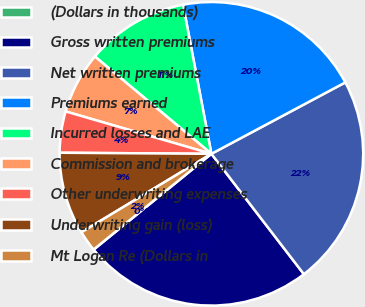Convert chart to OTSL. <chart><loc_0><loc_0><loc_500><loc_500><pie_chart><fcel>(Dollars in thousands)<fcel>Gross written premiums<fcel>Net written premiums<fcel>Premiums earned<fcel>Incurred losses and LAE<fcel>Commission and brokerage<fcel>Other underwriting expenses<fcel>Underwriting gain (loss)<fcel>Mt Logan Re (Dollars in<nl><fcel>0.02%<fcel>24.55%<fcel>22.37%<fcel>20.19%<fcel>10.94%<fcel>6.57%<fcel>4.39%<fcel>8.76%<fcel>2.21%<nl></chart> 